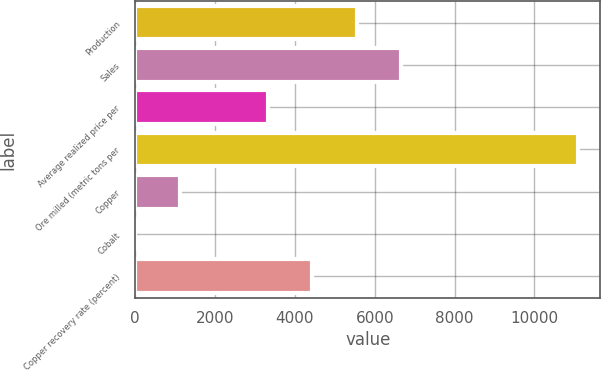<chart> <loc_0><loc_0><loc_500><loc_500><bar_chart><fcel>Production<fcel>Sales<fcel>Average realized price per<fcel>Ore milled (metric tons per<fcel>Copper<fcel>Cobalt<fcel>Copper recovery rate (percent)<nl><fcel>5550.2<fcel>6660.16<fcel>3330.28<fcel>11100<fcel>1110.36<fcel>0.4<fcel>4440.24<nl></chart> 